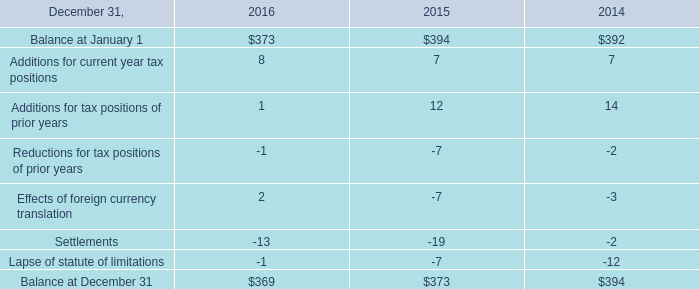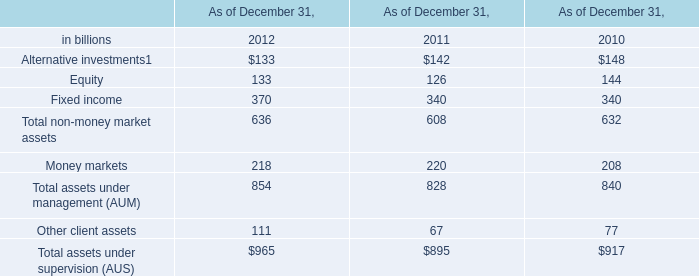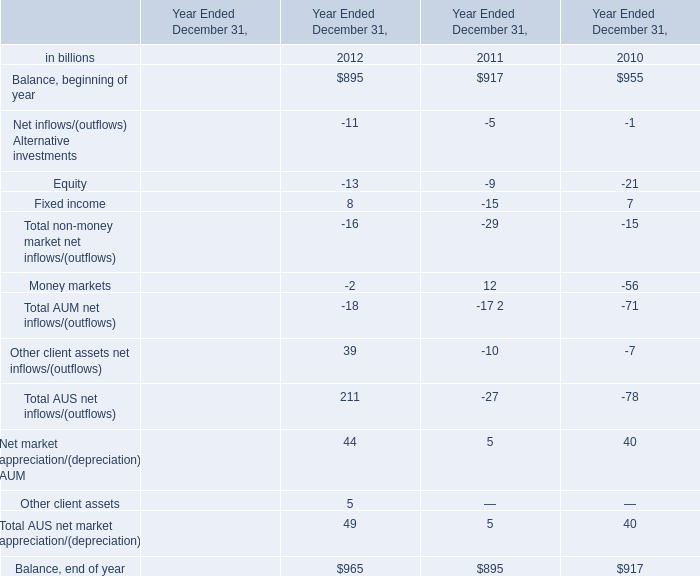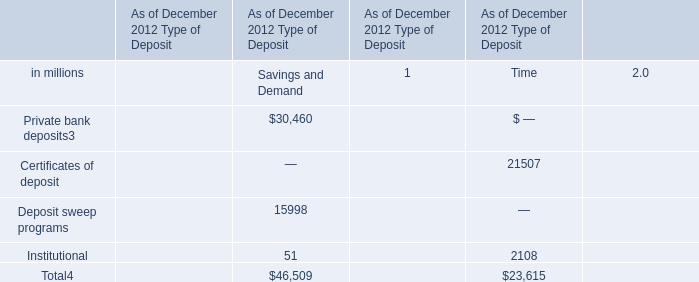Which year is Total non-money market assets the least? 
Answer: 2011. 